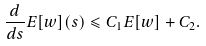Convert formula to latex. <formula><loc_0><loc_0><loc_500><loc_500>\frac { d } { d s } E [ w ] ( s ) \leqslant C _ { 1 } E [ w ] + C _ { 2 } .</formula> 